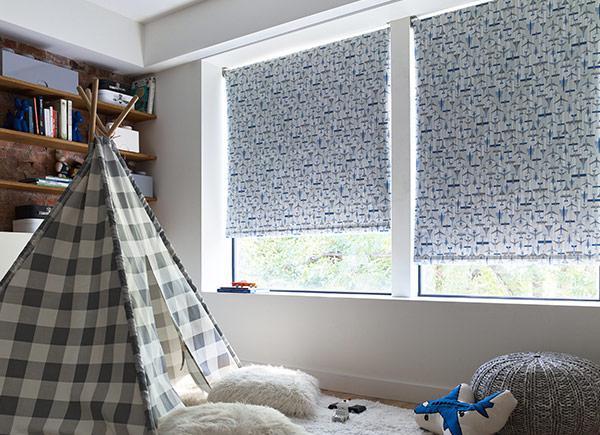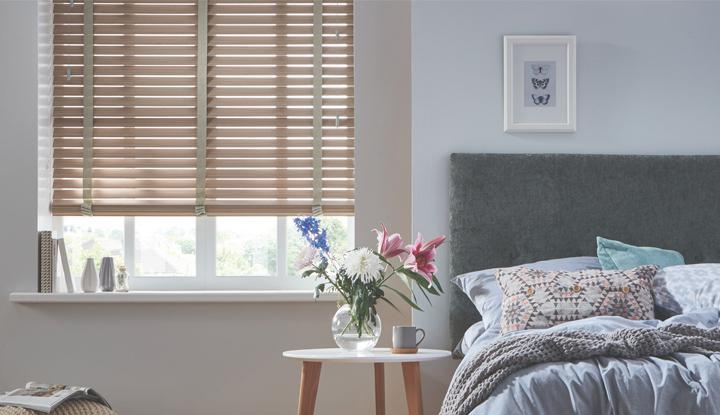The first image is the image on the left, the second image is the image on the right. For the images displayed, is the sentence "In at least one image there are two blinds that are both open at different levels." factually correct? Answer yes or no. Yes. The first image is the image on the left, the second image is the image on the right. Considering the images on both sides, is "The left image shows a chair to the right of a window with a pattern-printed window shade." valid? Answer yes or no. No. 